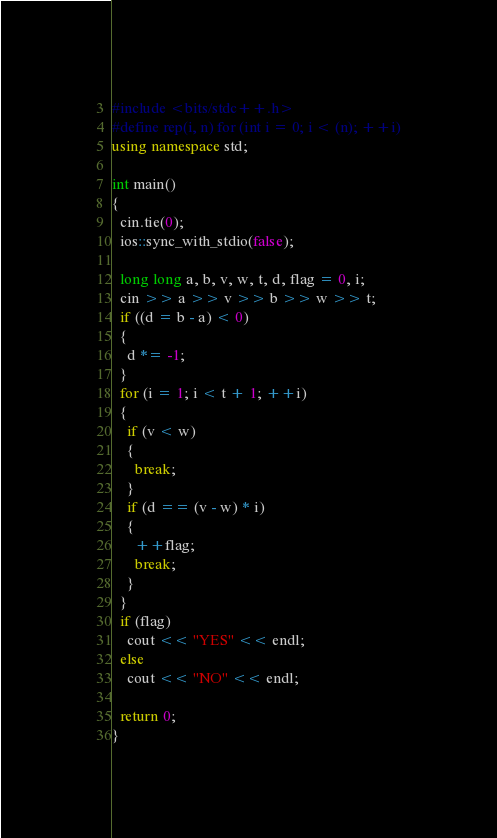Convert code to text. <code><loc_0><loc_0><loc_500><loc_500><_C++_>#include <bits/stdc++.h>
#define rep(i, n) for (int i = 0; i < (n); ++i)
using namespace std;

int main()
{
  cin.tie(0);
  ios::sync_with_stdio(false);

  long long a, b, v, w, t, d, flag = 0, i;
  cin >> a >> v >> b >> w >> t;
  if ((d = b - a) < 0)
  {
    d *= -1;
  }
  for (i = 1; i < t + 1; ++i)
  {
    if (v < w)
    {
      break;
    }
    if (d == (v - w) * i)
    {
      ++flag;
      break;
    }
  }
  if (flag)
    cout << "YES" << endl;
  else
    cout << "NO" << endl;

  return 0;
}</code> 